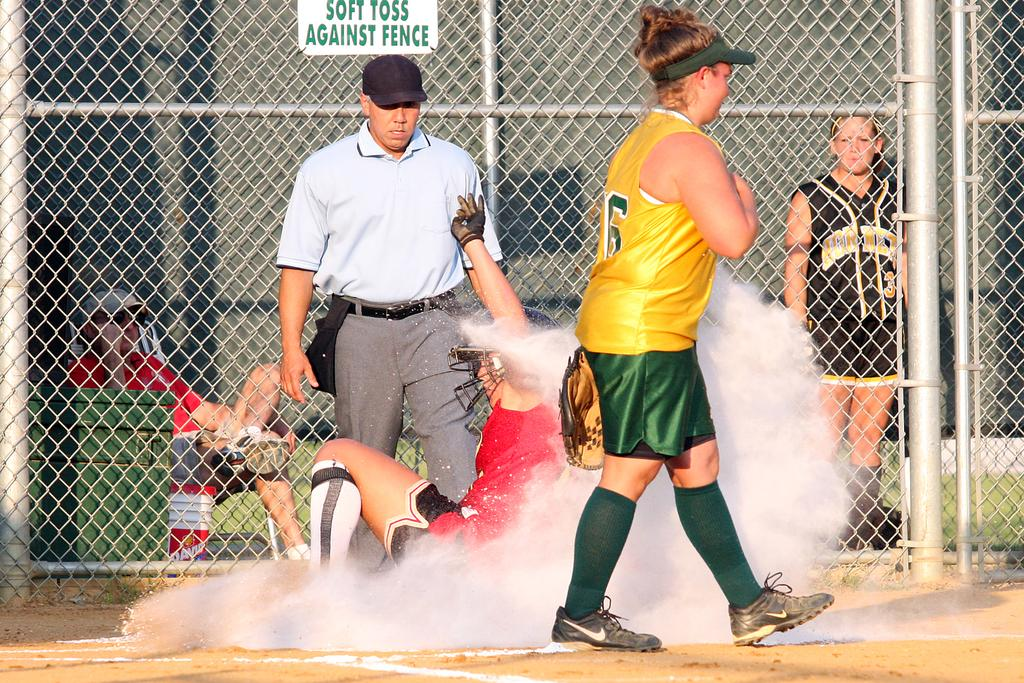Provide a one-sentence caption for the provided image. A sign on the chain link fence says that people should soft toss against the fence. 